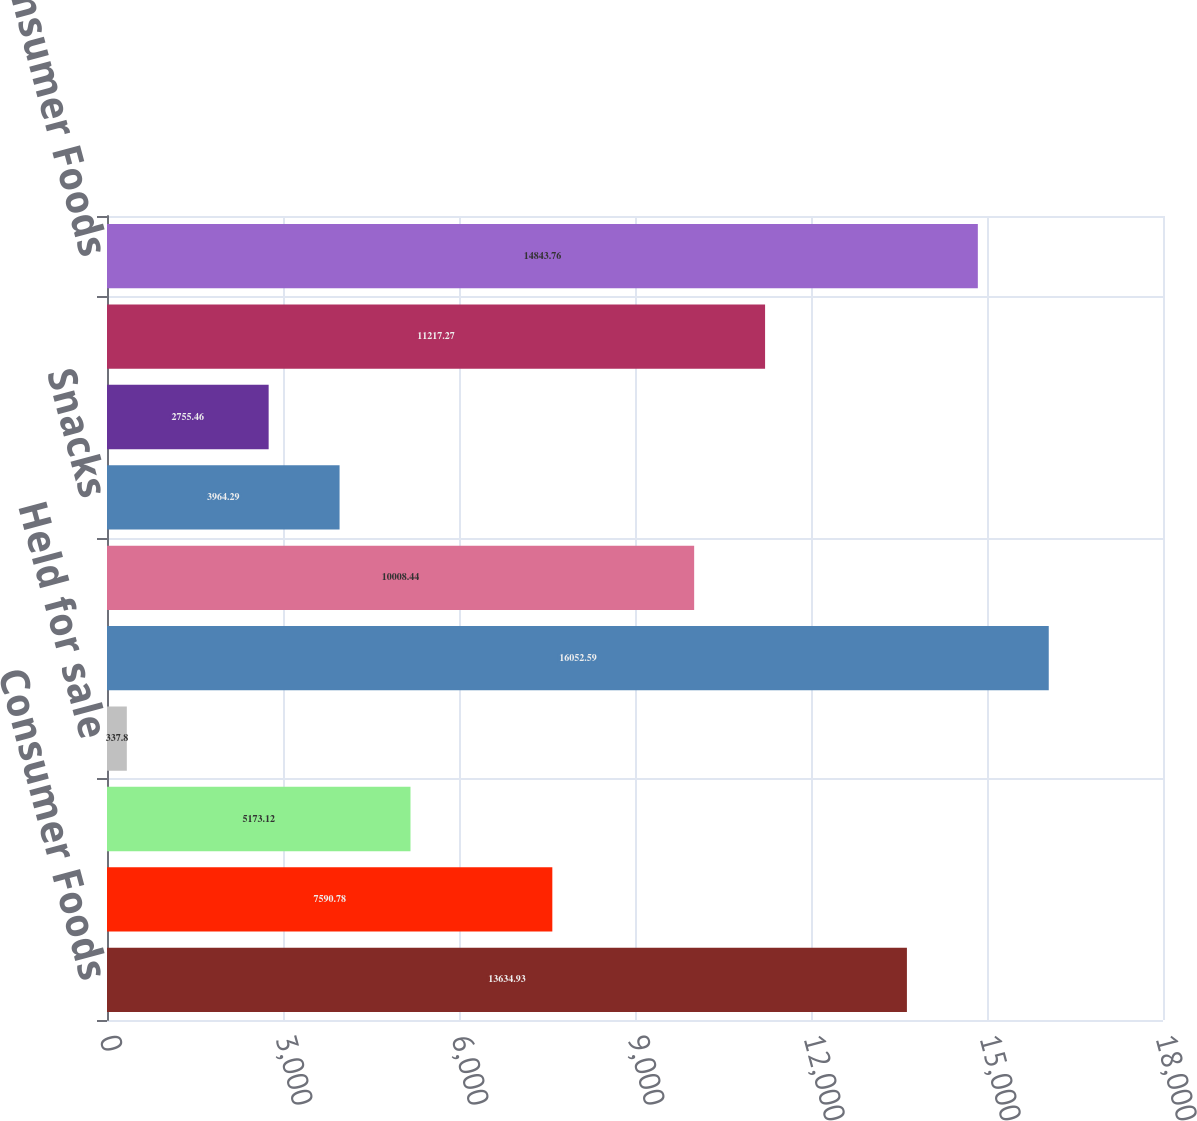<chart> <loc_0><loc_0><loc_500><loc_500><bar_chart><fcel>Consumer Foods<fcel>Commercial Foods<fcel>Corporate<fcel>Held for sale<fcel>Total<fcel>Convenient Meals<fcel>Snacks<fcel>Meal Enhancers<fcel>Specialty Foods<fcel>Total Consumer Foods<nl><fcel>13634.9<fcel>7590.78<fcel>5173.12<fcel>337.8<fcel>16052.6<fcel>10008.4<fcel>3964.29<fcel>2755.46<fcel>11217.3<fcel>14843.8<nl></chart> 